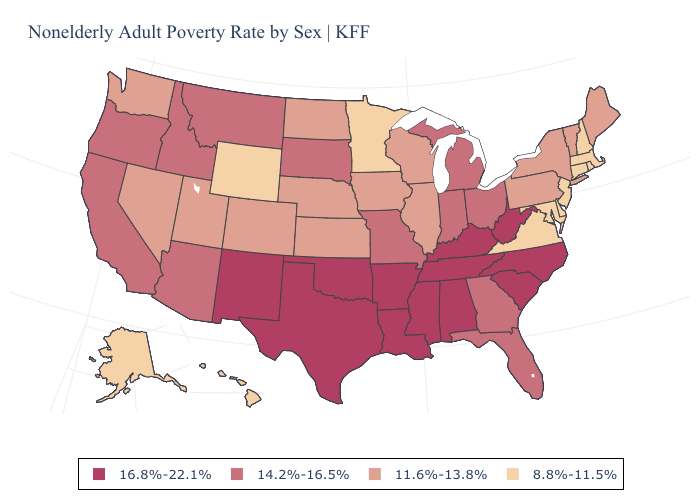Does the first symbol in the legend represent the smallest category?
Keep it brief. No. How many symbols are there in the legend?
Be succinct. 4. Name the states that have a value in the range 11.6%-13.8%?
Be succinct. Colorado, Illinois, Iowa, Kansas, Maine, Nebraska, Nevada, New York, North Dakota, Pennsylvania, Utah, Vermont, Washington, Wisconsin. Which states hav the highest value in the South?
Give a very brief answer. Alabama, Arkansas, Kentucky, Louisiana, Mississippi, North Carolina, Oklahoma, South Carolina, Tennessee, Texas, West Virginia. What is the lowest value in the South?
Concise answer only. 8.8%-11.5%. What is the lowest value in the USA?
Short answer required. 8.8%-11.5%. Does Virginia have the highest value in the South?
Concise answer only. No. Does the first symbol in the legend represent the smallest category?
Answer briefly. No. Name the states that have a value in the range 8.8%-11.5%?
Quick response, please. Alaska, Connecticut, Delaware, Hawaii, Maryland, Massachusetts, Minnesota, New Hampshire, New Jersey, Rhode Island, Virginia, Wyoming. Does Louisiana have the highest value in the USA?
Write a very short answer. Yes. Does Ohio have the lowest value in the MidWest?
Concise answer only. No. What is the value of Virginia?
Short answer required. 8.8%-11.5%. What is the value of Alabama?
Quick response, please. 16.8%-22.1%. What is the value of Massachusetts?
Keep it brief. 8.8%-11.5%. What is the value of New York?
Short answer required. 11.6%-13.8%. 